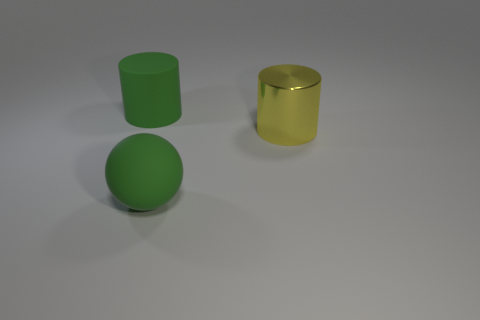Add 3 large things. How many objects exist? 6 Subtract all spheres. How many objects are left? 2 Add 1 rubber objects. How many rubber objects exist? 3 Subtract 1 green cylinders. How many objects are left? 2 Subtract all red balls. Subtract all yellow blocks. How many balls are left? 1 Subtract all matte objects. Subtract all large green spheres. How many objects are left? 0 Add 1 green matte objects. How many green matte objects are left? 3 